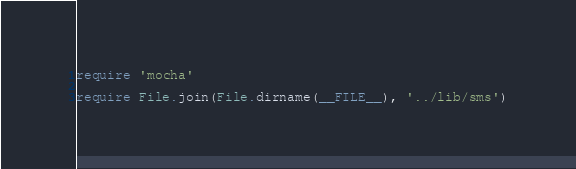<code> <loc_0><loc_0><loc_500><loc_500><_Ruby_>require 'mocha'

require File.join(File.dirname(__FILE__), '../lib/sms')
</code> 